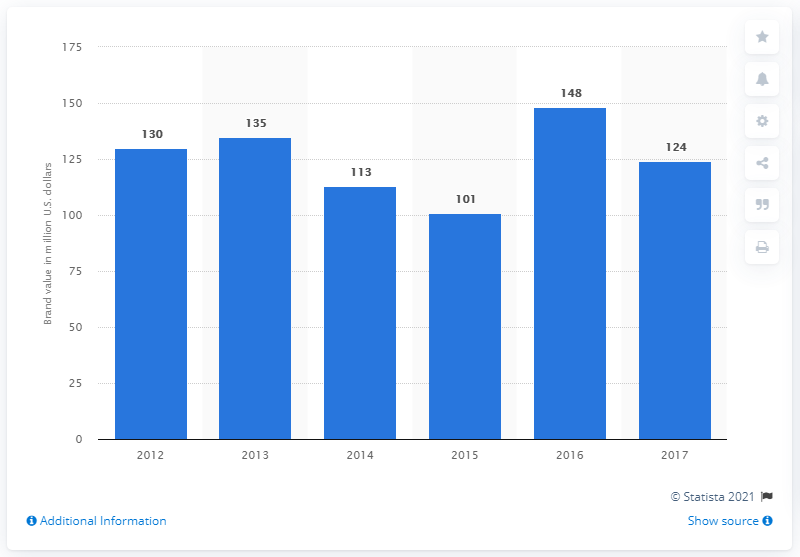Draw attention to some important aspects in this diagram. In 2017, the brand value of the MLB World Series was estimated to be 124. 